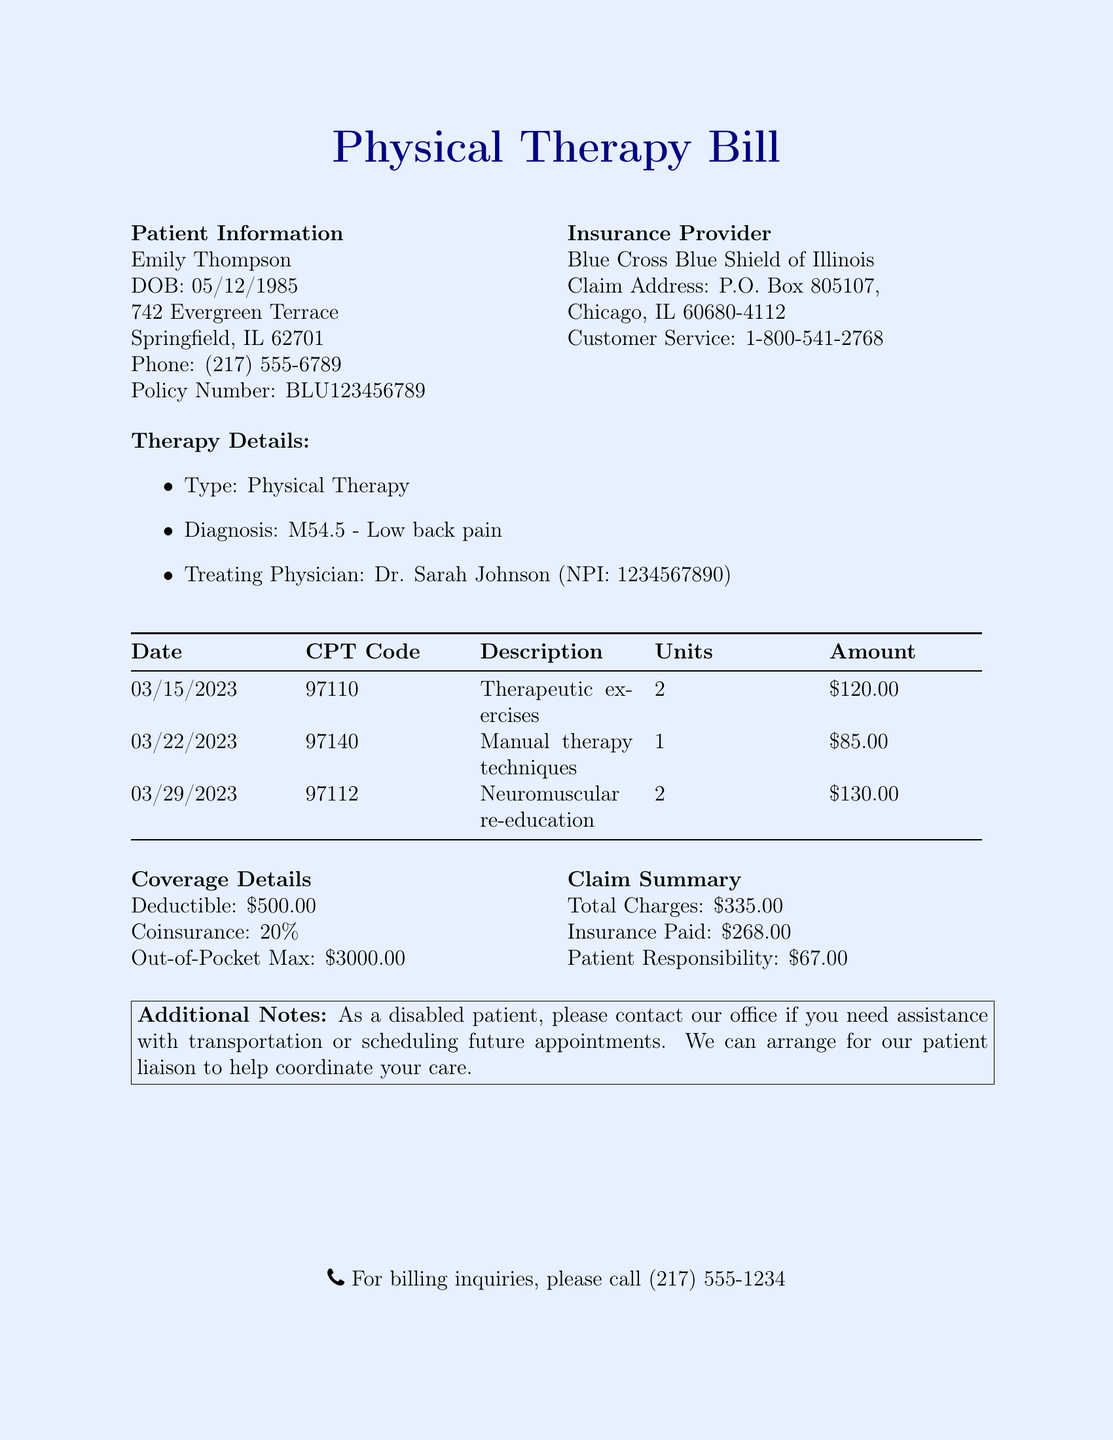What is the patient's name? The patient's name is listed in the document under Patient Information.
Answer: Emily Thompson What is the policy number? The policy number is found in the Patient Information section.
Answer: BLU123456789 What is the total charge for physical therapy sessions? The total charge can be found in the Claim Summary section of the document.
Answer: $335.00 What is the amount that the insurance paid? The amount paid by the insurance is detailed in the Claim Summary.
Answer: $268.00 What is the patient's responsibility? The patient's responsibility is indicated in the Claim Summary section.
Answer: $67.00 How many therapy sessions are documented? The number of therapy sessions can be counted in the Therapy Details section.
Answer: 3 What is the deductible amount? The deductible amount is stated in the Coverage Details section of the document.
Answer: $500.00 Who is the treating physician? The name of the treating physician is provided in the Therapy Details section.
Answer: Dr. Sarah Johnson What is the out-of-pocket maximum? The out-of-pocket maximum is outlined in the Coverage Details.
Answer: $3000.00 What is the phone number for billing inquiries? The phone number for billing inquiries is mentioned at the bottom of the document.
Answer: (217) 555-1234 